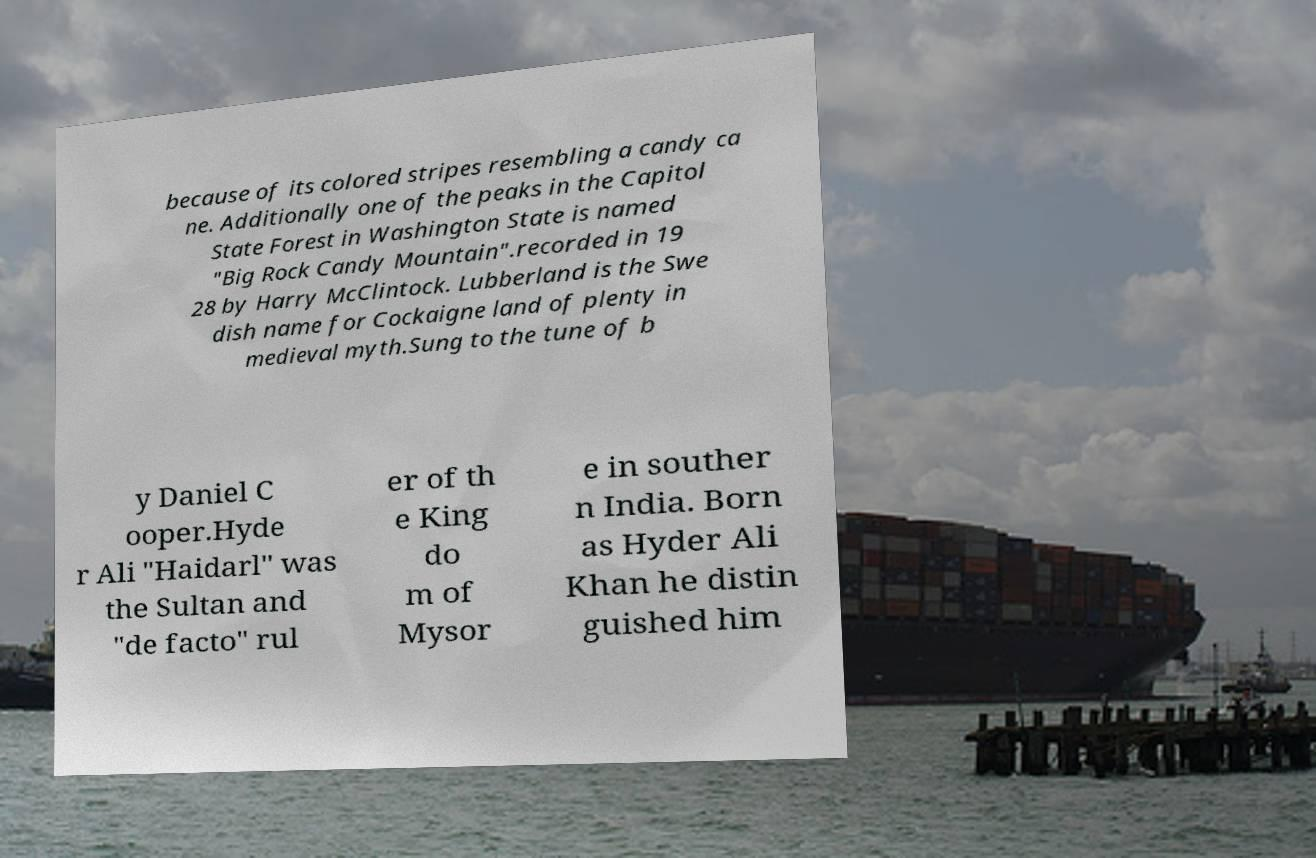I need the written content from this picture converted into text. Can you do that? because of its colored stripes resembling a candy ca ne. Additionally one of the peaks in the Capitol State Forest in Washington State is named "Big Rock Candy Mountain".recorded in 19 28 by Harry McClintock. Lubberland is the Swe dish name for Cockaigne land of plenty in medieval myth.Sung to the tune of b y Daniel C ooper.Hyde r Ali "Haidarl" was the Sultan and "de facto" rul er of th e King do m of Mysor e in souther n India. Born as Hyder Ali Khan he distin guished him 